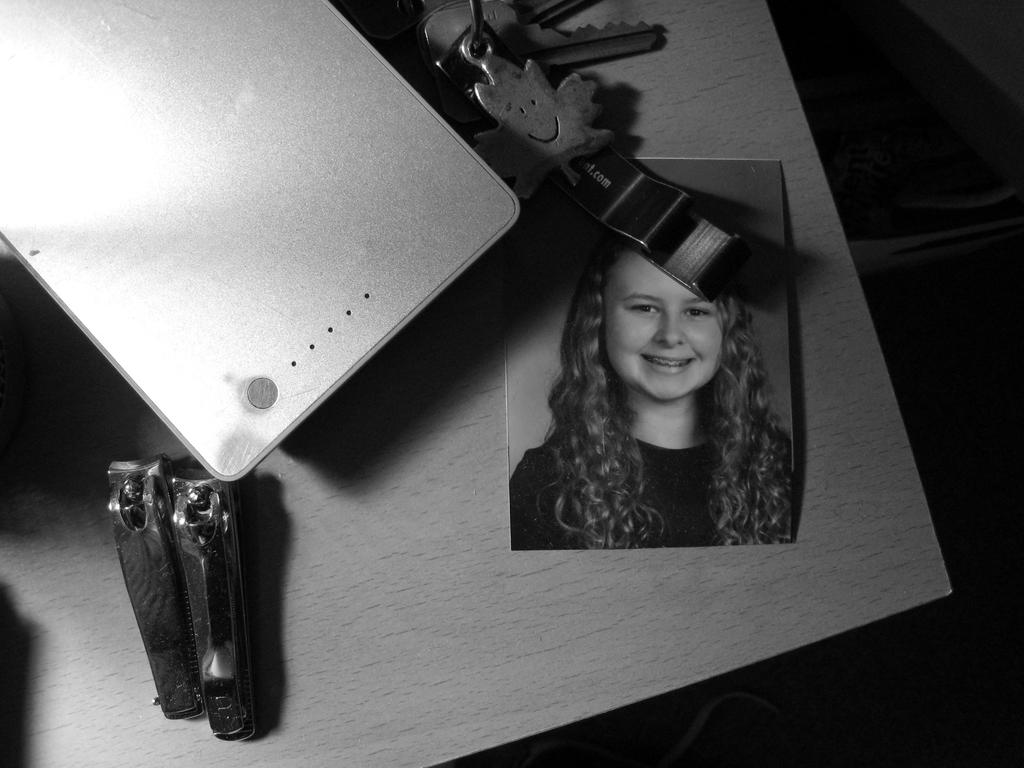What is on the table in the image? There is a photograph and two nail cutters on the table. What else can be seen on the table besides the photograph and nail cutters? There are other objects on the table. What type of game is being played in the image? There is no game being played in the image; it only shows a photograph and nail cutters on a table. How many cows are visible in the image? There are no cows present in the image. 